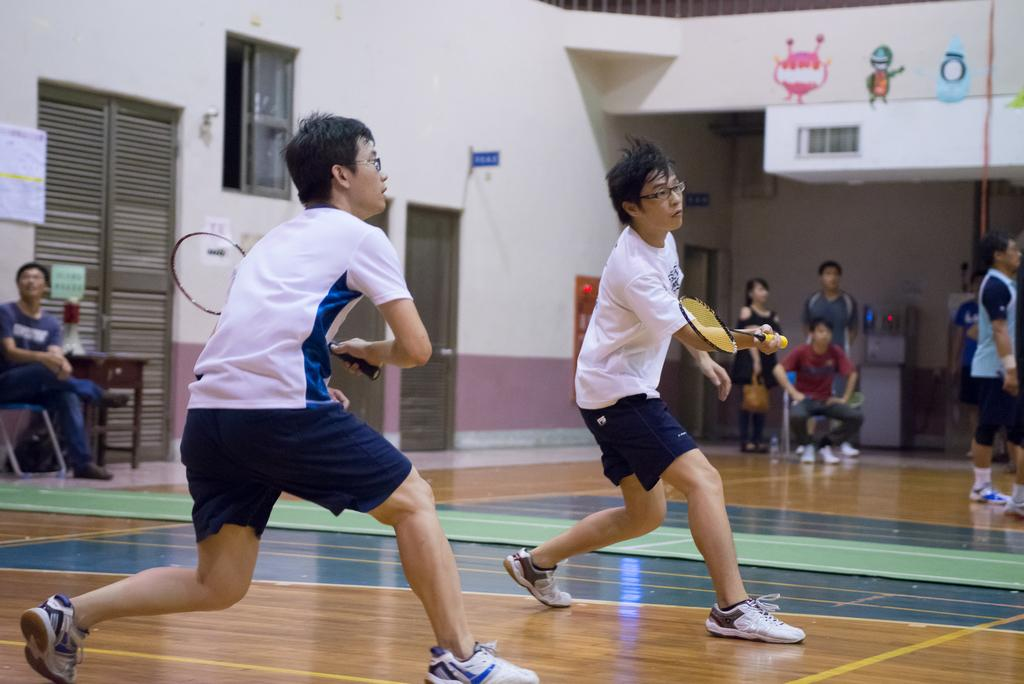How many men are in the image? There are two men in the image. What are the men holding in the image? The men are holding a bat. What can be seen in the background of the image? There is a wall and people in the background of the image. What are the positions of the people in the background? Two of the people are sitting, and the rest are standing. What type of development can be seen in the image? There is no development project visible in the image; it features two men holding a bat and people in the background. What is the frame made of in the image? There is no frame present in the image; it is a photograph of two men holding a bat and people in the background. 